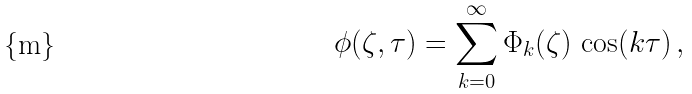Convert formula to latex. <formula><loc_0><loc_0><loc_500><loc_500>\phi ( \zeta , \tau ) = \sum _ { k = 0 } ^ { \infty } \Phi _ { k } ( \zeta ) \, \cos ( k \tau ) \, ,</formula> 